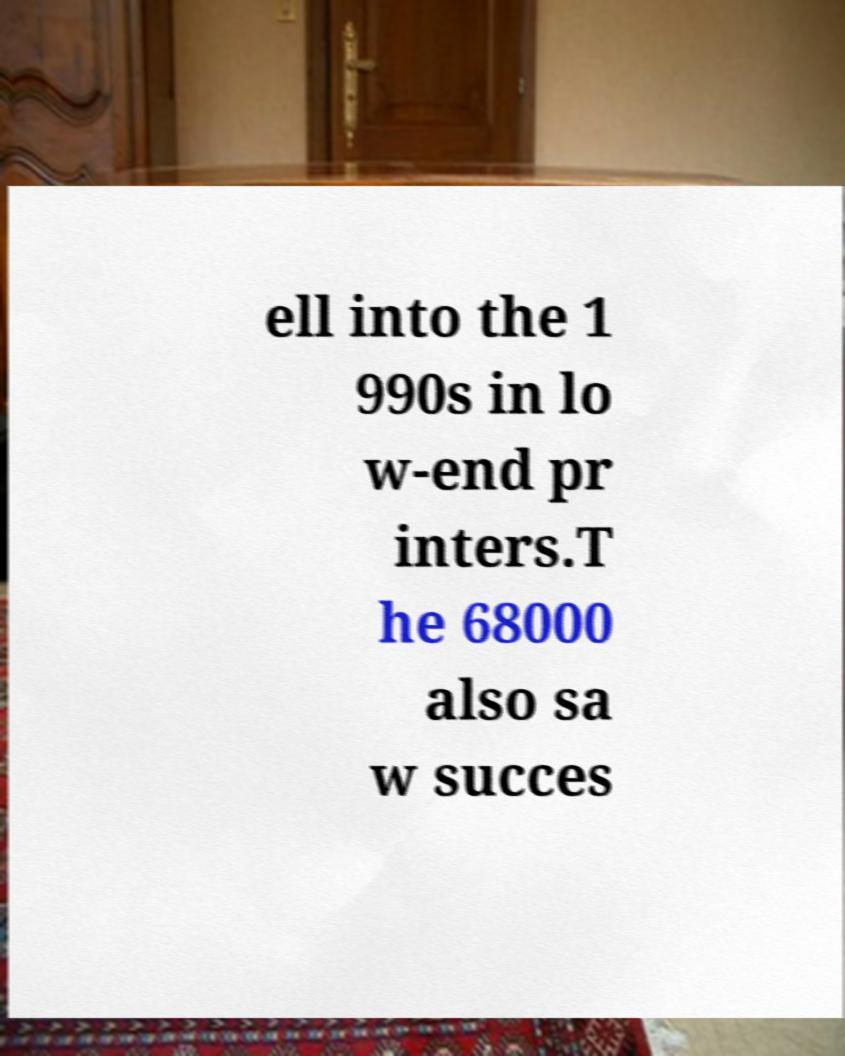There's text embedded in this image that I need extracted. Can you transcribe it verbatim? ell into the 1 990s in lo w-end pr inters.T he 68000 also sa w succes 